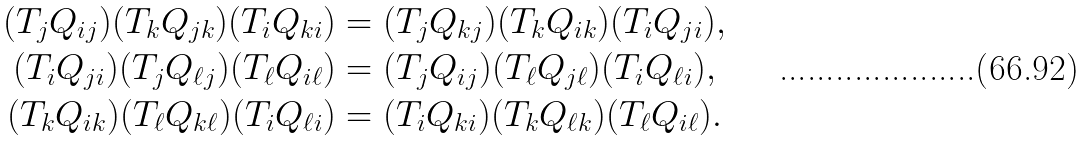Convert formula to latex. <formula><loc_0><loc_0><loc_500><loc_500>( T _ { j } Q _ { i j } ) ( T _ { k } Q _ { j k } ) ( T _ { i } Q _ { k i } ) & = ( T _ { j } Q _ { k j } ) ( T _ { k } Q _ { i k } ) ( T _ { i } Q _ { j i } ) , \\ ( T _ { i } Q _ { j i } ) ( T _ { j } Q _ { \ell j } ) ( T _ { \ell } Q _ { i \ell } ) & = ( T _ { j } Q _ { i j } ) ( T _ { \ell } Q _ { j \ell } ) ( T _ { i } Q _ { \ell i } ) , \\ ( T _ { k } Q _ { i k } ) ( T _ { \ell } Q _ { k \ell } ) ( T _ { i } Q _ { \ell i } ) & = ( T _ { i } Q _ { k i } ) ( T _ { k } Q _ { \ell k } ) ( T _ { \ell } Q _ { i \ell } ) .</formula> 